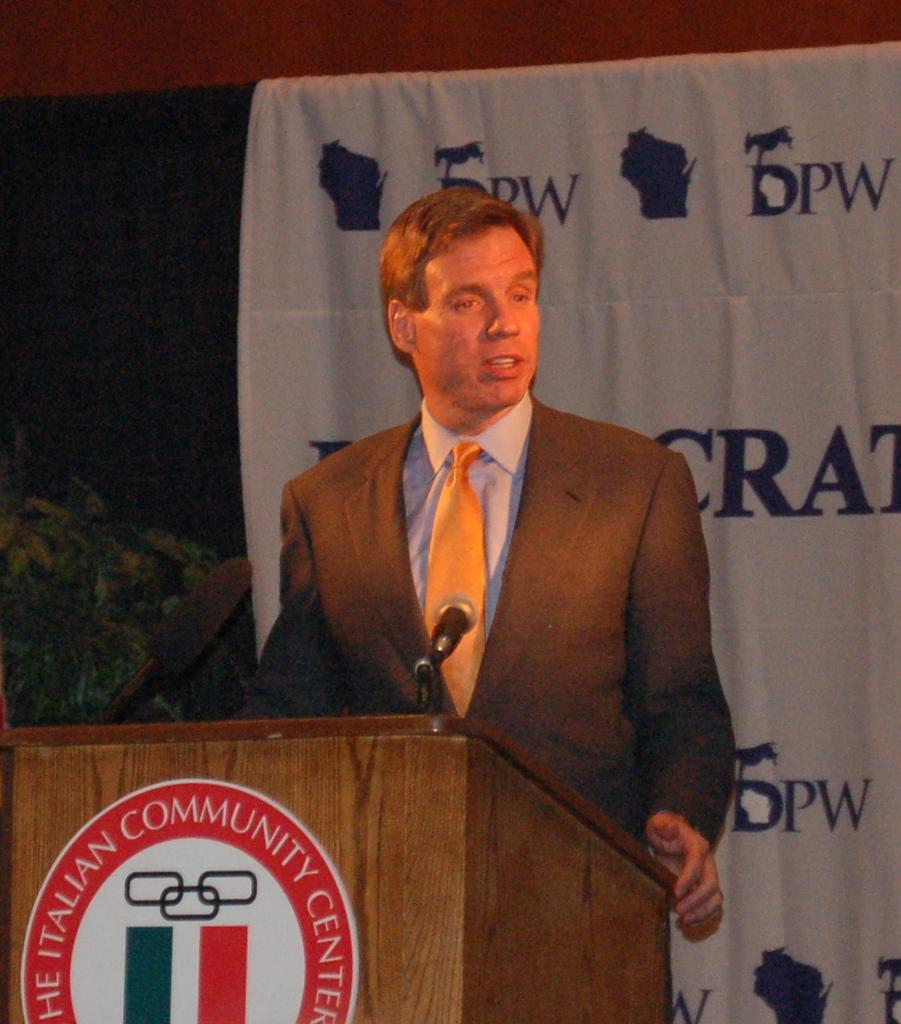Can you describe this image briefly? This picture might be taken inside a conference hall. In this image, in the middle, there is a man wearing a black color suit is standing in front of a podium. On that podium, we can see a microphone. On the left side of the image, there are some plants. In the background, we can see black color and white color cloth. 